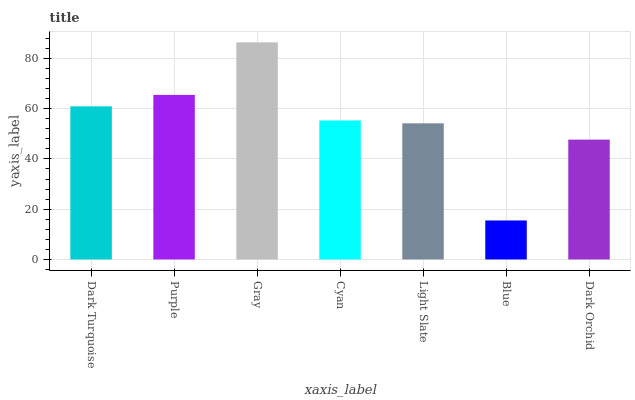Is Blue the minimum?
Answer yes or no. Yes. Is Gray the maximum?
Answer yes or no. Yes. Is Purple the minimum?
Answer yes or no. No. Is Purple the maximum?
Answer yes or no. No. Is Purple greater than Dark Turquoise?
Answer yes or no. Yes. Is Dark Turquoise less than Purple?
Answer yes or no. Yes. Is Dark Turquoise greater than Purple?
Answer yes or no. No. Is Purple less than Dark Turquoise?
Answer yes or no. No. Is Cyan the high median?
Answer yes or no. Yes. Is Cyan the low median?
Answer yes or no. Yes. Is Dark Orchid the high median?
Answer yes or no. No. Is Blue the low median?
Answer yes or no. No. 